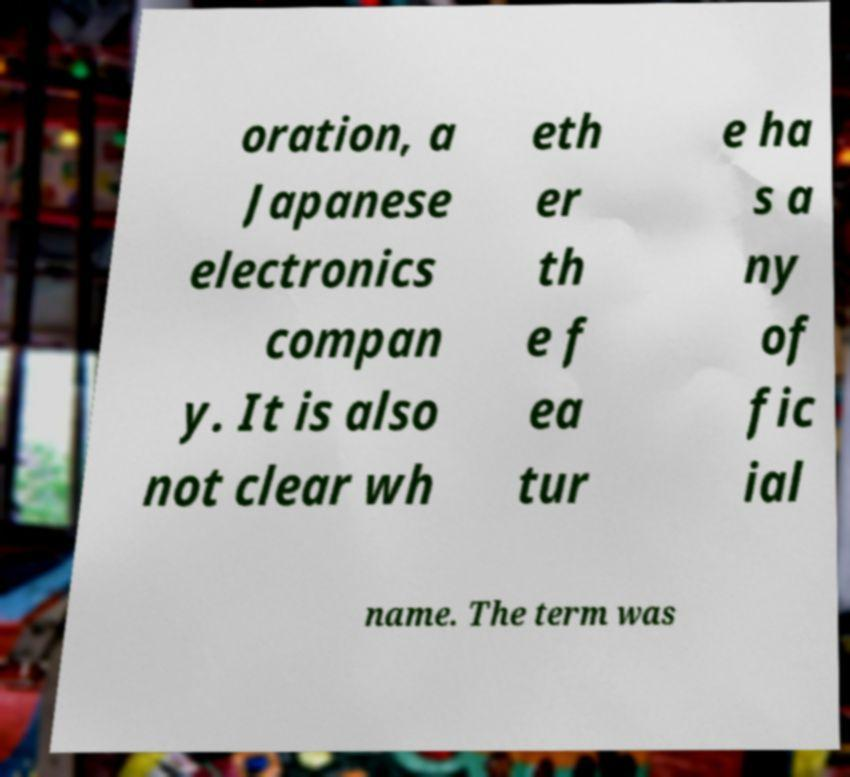Could you assist in decoding the text presented in this image and type it out clearly? oration, a Japanese electronics compan y. It is also not clear wh eth er th e f ea tur e ha s a ny of fic ial name. The term was 